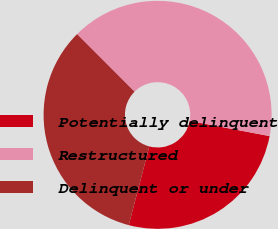Convert chart. <chart><loc_0><loc_0><loc_500><loc_500><pie_chart><fcel>Potentially delinquent<fcel>Restructured<fcel>Delinquent or under<nl><fcel>26.09%<fcel>40.47%<fcel>33.44%<nl></chart> 